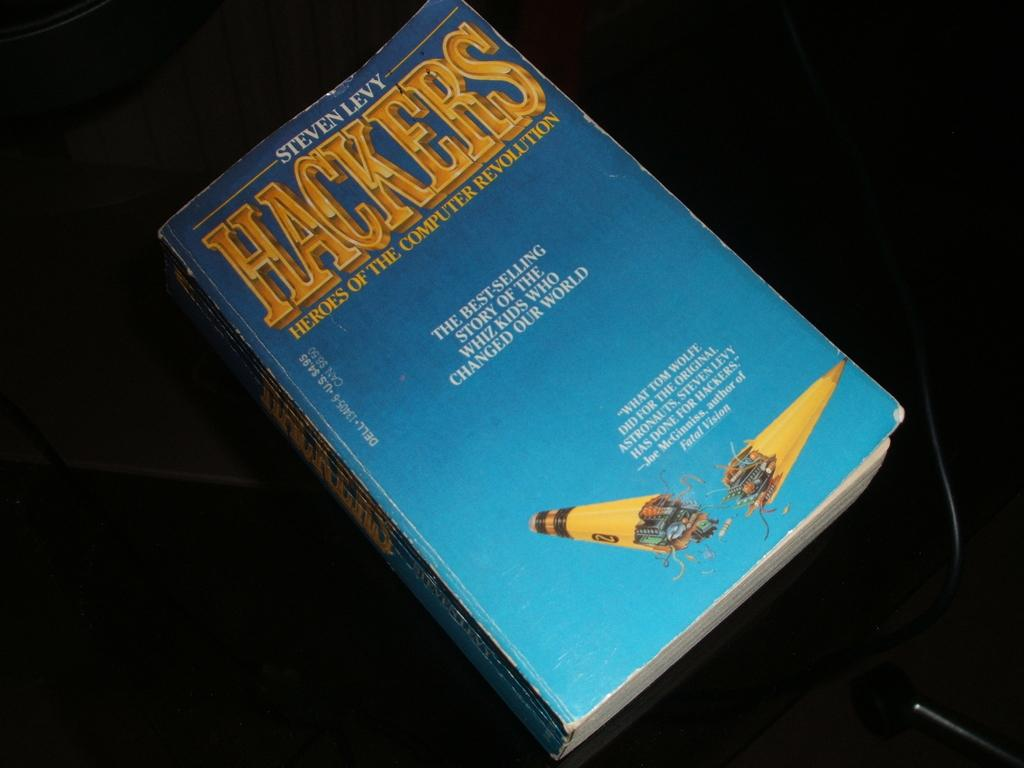<image>
Give a short and clear explanation of the subsequent image. Paperback HACKERS book with sky blue background and broken number 2 yellow pencil cover. 